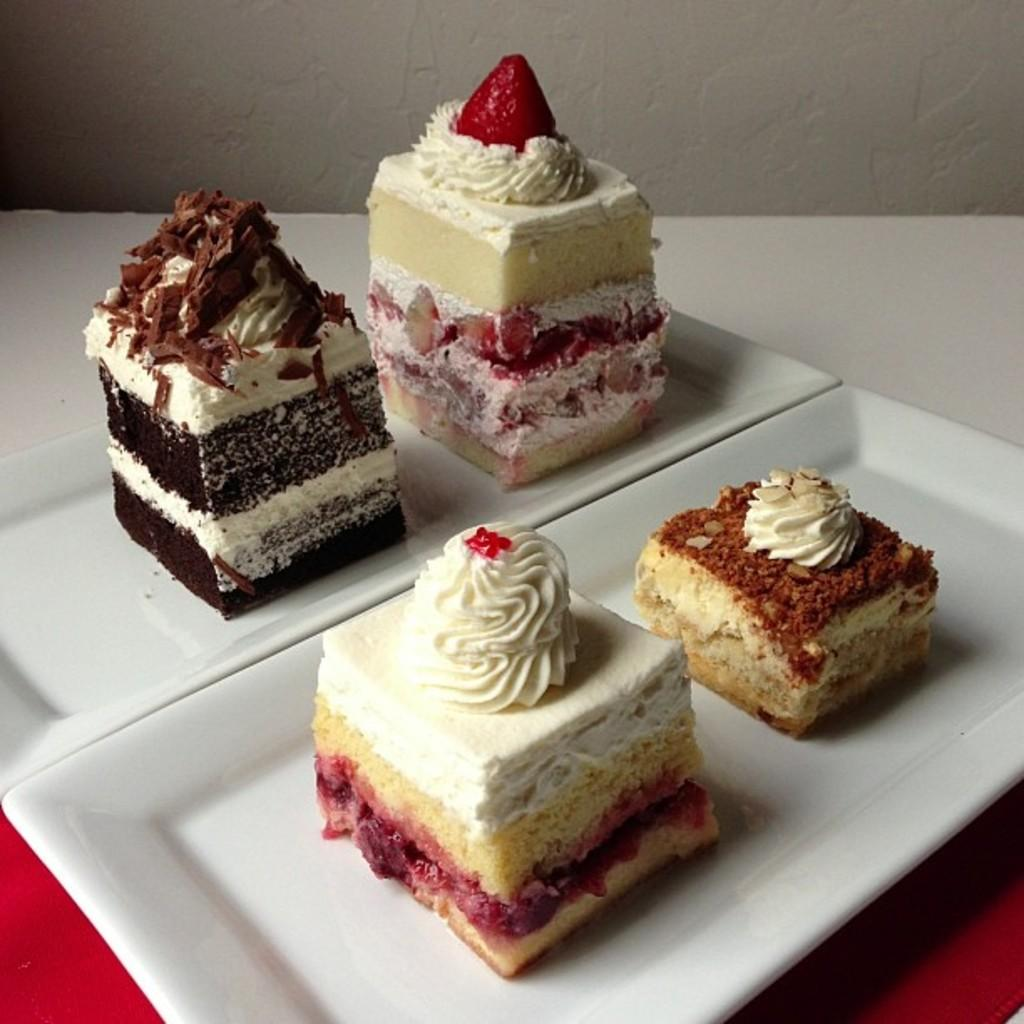How many cake pieces are visible in the image? There are four cake pieces in the image. What are the cake pieces placed on? The cake pieces are on white plates. What color is the cloth under the plates? The plates are placed on a red cloth. What can be seen in the background of the image? There is a wall in the background of the image. How many cars are parked at the station in the image? There are no cars or stations present in the image; it features four cake pieces on white plates placed on a red cloth. 